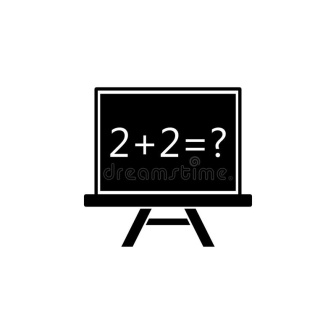What other elements could be added to this image to make it more complex? To make the image more complex, various elements could be added. For instance, adding a student's desk with an open notebook showing scribbled and erased attempts at solving the equation could introduce narrative depth. Surrounding the chalkboard with mathematical symbols and equations on nearby blackboards or posters could contribute to a richer educational context. Even a backdrop showing a typical classroom window with a view of a playground, or placing a teacher standing beside the board, could further enhance the story and setting. 